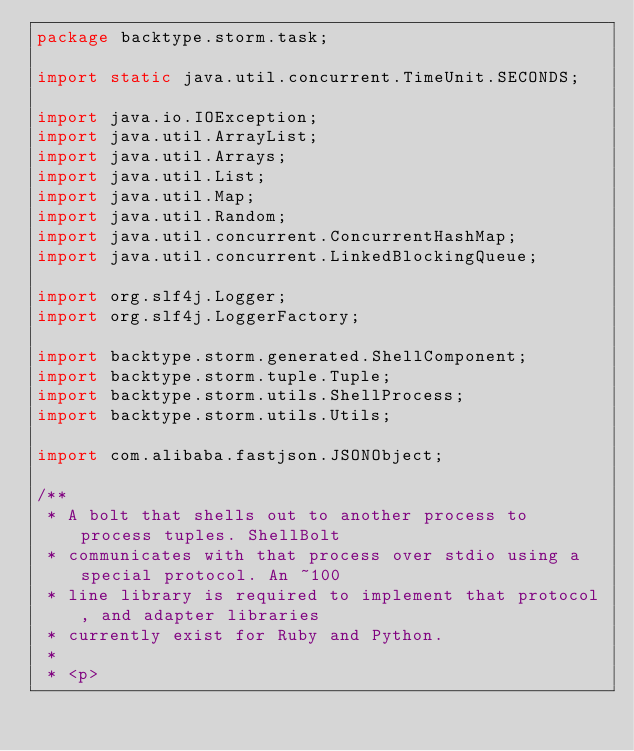<code> <loc_0><loc_0><loc_500><loc_500><_Java_>package backtype.storm.task;

import static java.util.concurrent.TimeUnit.SECONDS;

import java.io.IOException;
import java.util.ArrayList;
import java.util.Arrays;
import java.util.List;
import java.util.Map;
import java.util.Random;
import java.util.concurrent.ConcurrentHashMap;
import java.util.concurrent.LinkedBlockingQueue;

import org.slf4j.Logger;
import org.slf4j.LoggerFactory;

import backtype.storm.generated.ShellComponent;
import backtype.storm.tuple.Tuple;
import backtype.storm.utils.ShellProcess;
import backtype.storm.utils.Utils;

import com.alibaba.fastjson.JSONObject;

/**
 * A bolt that shells out to another process to process tuples. ShellBolt
 * communicates with that process over stdio using a special protocol. An ~100
 * line library is required to implement that protocol, and adapter libraries
 * currently exist for Ruby and Python.
 * 
 * <p></code> 